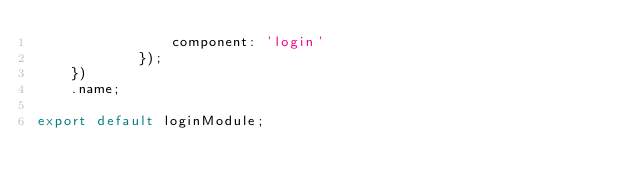<code> <loc_0><loc_0><loc_500><loc_500><_JavaScript_>                component: 'login'
            });
    })
    .name;

export default loginModule;
</code> 